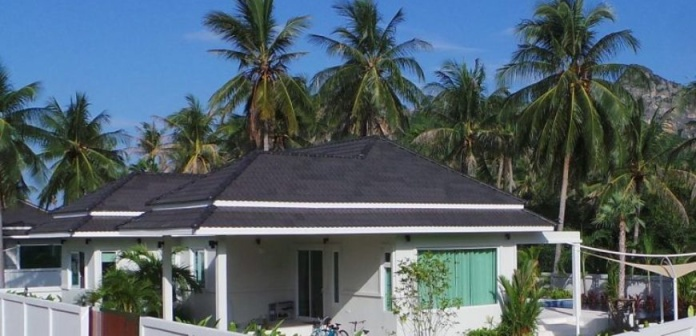Can you tell me more about the style of the house? The house showcased in the image is a single-floor bungalow that exudes a blend of tropical and contemporary style. Its white walls and black gabled roof create a classic, timeless look, while the green shutters provide a tropical flair, enhancing its charm. It's a style well-suited for the coastal climate, likely designed for comfortable living with good ventilation and shade. It looks quite peaceful; do you think this location is popular with tourists? Given the serene atmosphere and the presence of natural beauty, it's plausible that this area appeals to tourists seeking a tranquil retreat. However, the absence of bustling activity in the image suggests it might be a less frequented spot, offering a more private and intimate experience for visitors and locals alike. 